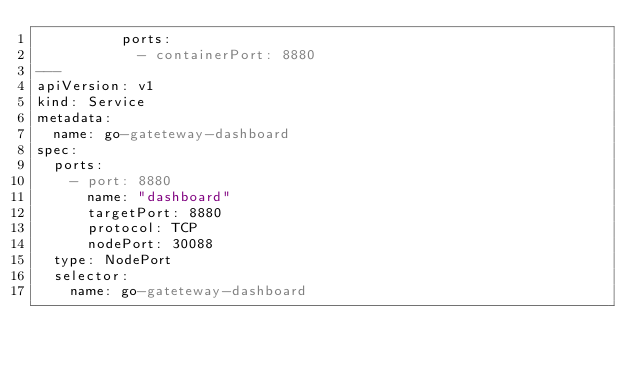<code> <loc_0><loc_0><loc_500><loc_500><_YAML_>          ports:
            - containerPort: 8880
---
apiVersion: v1
kind: Service
metadata:
  name: go-gateteway-dashboard
spec:
  ports:
    - port: 8880
      name: "dashboard"
      targetPort: 8880
      protocol: TCP
      nodePort: 30088
  type: NodePort
  selector:
    name: go-gateteway-dashboard</code> 